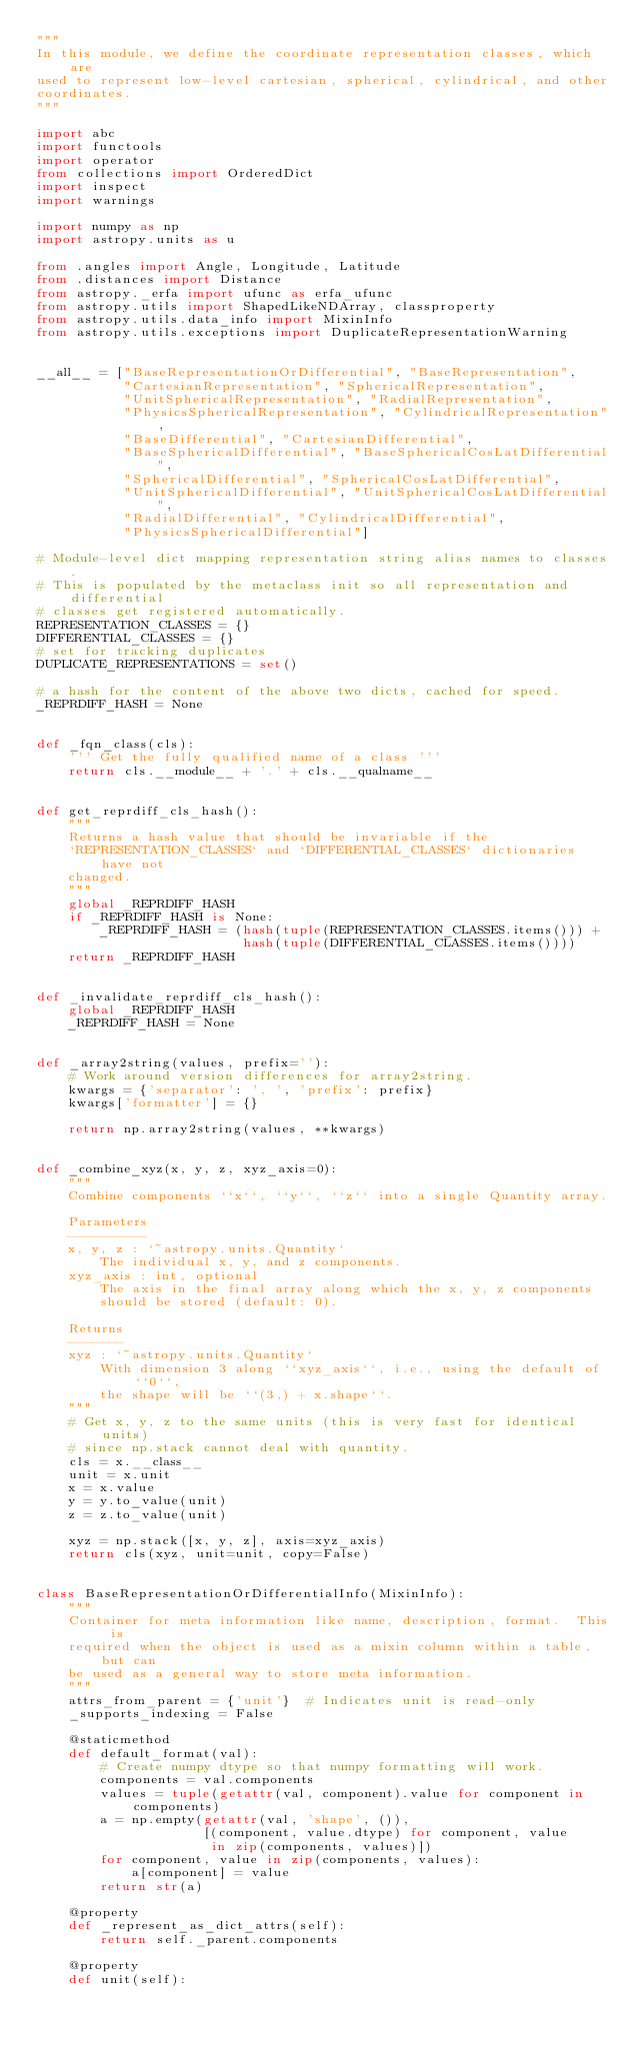<code> <loc_0><loc_0><loc_500><loc_500><_Python_>"""
In this module, we define the coordinate representation classes, which are
used to represent low-level cartesian, spherical, cylindrical, and other
coordinates.
"""

import abc
import functools
import operator
from collections import OrderedDict
import inspect
import warnings

import numpy as np
import astropy.units as u

from .angles import Angle, Longitude, Latitude
from .distances import Distance
from astropy._erfa import ufunc as erfa_ufunc
from astropy.utils import ShapedLikeNDArray, classproperty
from astropy.utils.data_info import MixinInfo
from astropy.utils.exceptions import DuplicateRepresentationWarning


__all__ = ["BaseRepresentationOrDifferential", "BaseRepresentation",
           "CartesianRepresentation", "SphericalRepresentation",
           "UnitSphericalRepresentation", "RadialRepresentation",
           "PhysicsSphericalRepresentation", "CylindricalRepresentation",
           "BaseDifferential", "CartesianDifferential",
           "BaseSphericalDifferential", "BaseSphericalCosLatDifferential",
           "SphericalDifferential", "SphericalCosLatDifferential",
           "UnitSphericalDifferential", "UnitSphericalCosLatDifferential",
           "RadialDifferential", "CylindricalDifferential",
           "PhysicsSphericalDifferential"]

# Module-level dict mapping representation string alias names to classes.
# This is populated by the metaclass init so all representation and differential
# classes get registered automatically.
REPRESENTATION_CLASSES = {}
DIFFERENTIAL_CLASSES = {}
# set for tracking duplicates
DUPLICATE_REPRESENTATIONS = set()

# a hash for the content of the above two dicts, cached for speed.
_REPRDIFF_HASH = None


def _fqn_class(cls):
    ''' Get the fully qualified name of a class '''
    return cls.__module__ + '.' + cls.__qualname__


def get_reprdiff_cls_hash():
    """
    Returns a hash value that should be invariable if the
    `REPRESENTATION_CLASSES` and `DIFFERENTIAL_CLASSES` dictionaries have not
    changed.
    """
    global _REPRDIFF_HASH
    if _REPRDIFF_HASH is None:
        _REPRDIFF_HASH = (hash(tuple(REPRESENTATION_CLASSES.items())) +
                          hash(tuple(DIFFERENTIAL_CLASSES.items())))
    return _REPRDIFF_HASH


def _invalidate_reprdiff_cls_hash():
    global _REPRDIFF_HASH
    _REPRDIFF_HASH = None


def _array2string(values, prefix=''):
    # Work around version differences for array2string.
    kwargs = {'separator': ', ', 'prefix': prefix}
    kwargs['formatter'] = {}

    return np.array2string(values, **kwargs)


def _combine_xyz(x, y, z, xyz_axis=0):
    """
    Combine components ``x``, ``y``, ``z`` into a single Quantity array.

    Parameters
    ----------
    x, y, z : `~astropy.units.Quantity`
        The individual x, y, and z components.
    xyz_axis : int, optional
        The axis in the final array along which the x, y, z components
        should be stored (default: 0).

    Returns
    -------
    xyz : `~astropy.units.Quantity`
        With dimension 3 along ``xyz_axis``, i.e., using the default of ``0``,
        the shape will be ``(3,) + x.shape``.
    """
    # Get x, y, z to the same units (this is very fast for identical units)
    # since np.stack cannot deal with quantity.
    cls = x.__class__
    unit = x.unit
    x = x.value
    y = y.to_value(unit)
    z = z.to_value(unit)

    xyz = np.stack([x, y, z], axis=xyz_axis)
    return cls(xyz, unit=unit, copy=False)


class BaseRepresentationOrDifferentialInfo(MixinInfo):
    """
    Container for meta information like name, description, format.  This is
    required when the object is used as a mixin column within a table, but can
    be used as a general way to store meta information.
    """
    attrs_from_parent = {'unit'}  # Indicates unit is read-only
    _supports_indexing = False

    @staticmethod
    def default_format(val):
        # Create numpy dtype so that numpy formatting will work.
        components = val.components
        values = tuple(getattr(val, component).value for component in components)
        a = np.empty(getattr(val, 'shape', ()),
                     [(component, value.dtype) for component, value
                      in zip(components, values)])
        for component, value in zip(components, values):
            a[component] = value
        return str(a)

    @property
    def _represent_as_dict_attrs(self):
        return self._parent.components

    @property
    def unit(self):</code> 